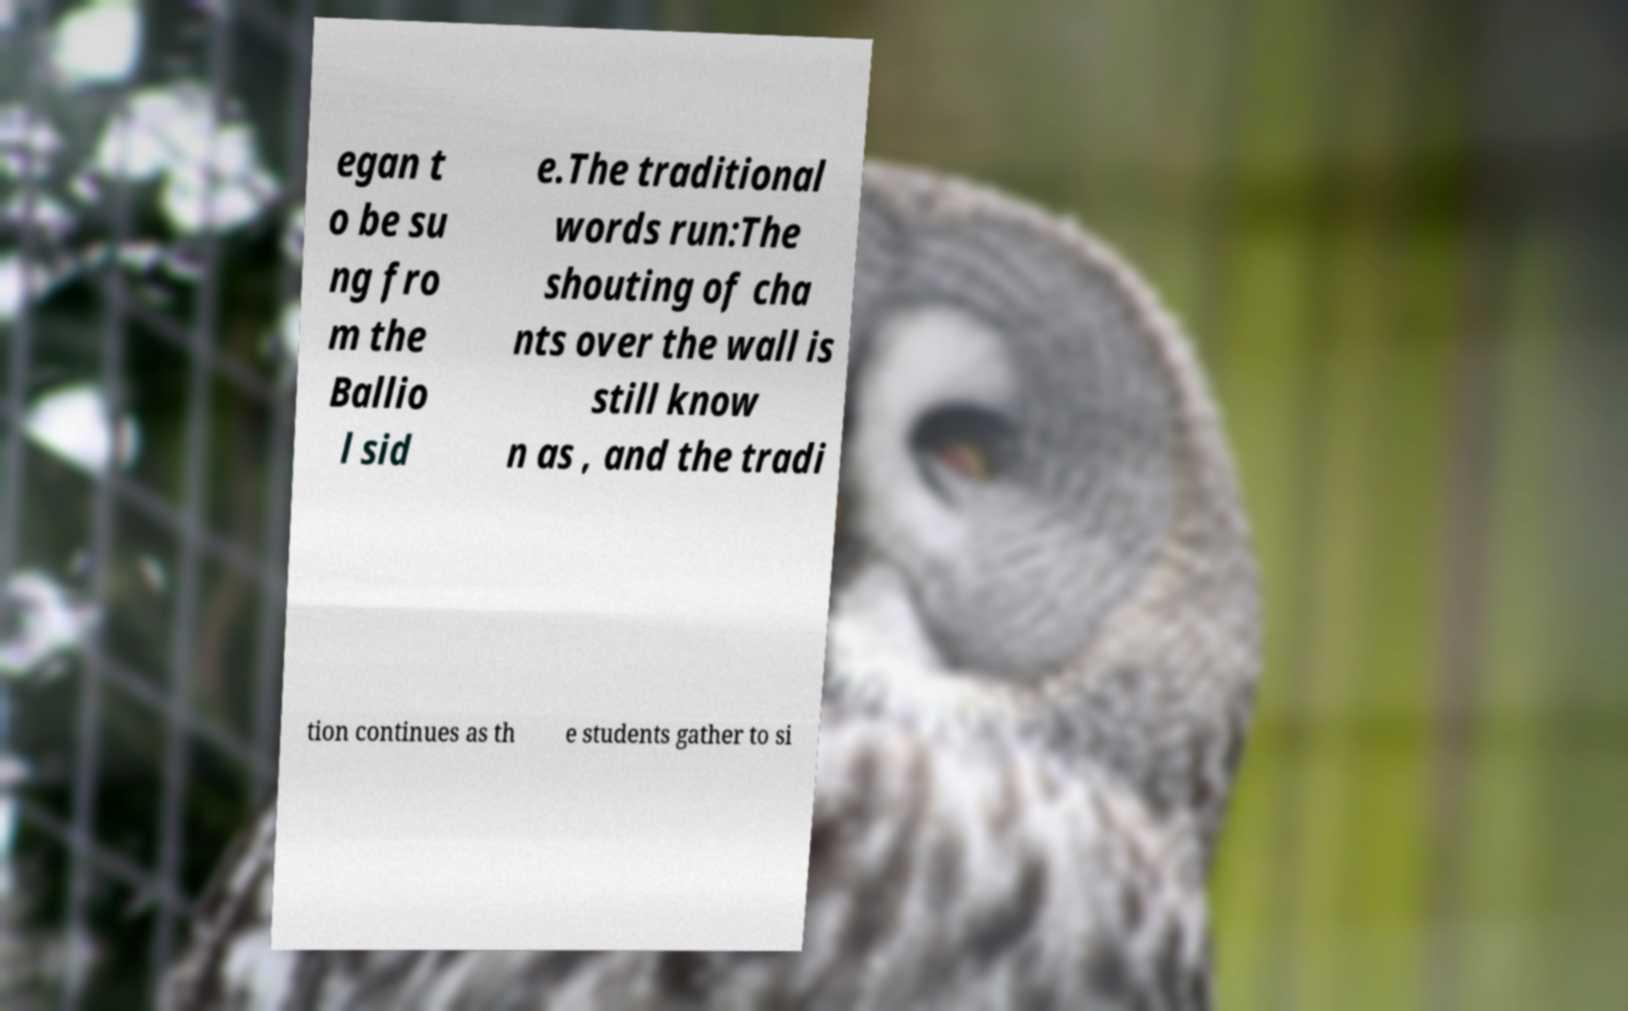Could you assist in decoding the text presented in this image and type it out clearly? egan t o be su ng fro m the Ballio l sid e.The traditional words run:The shouting of cha nts over the wall is still know n as , and the tradi tion continues as th e students gather to si 